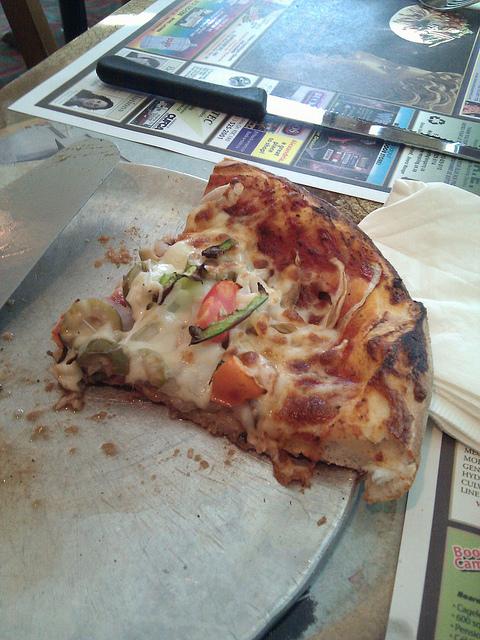How many pieces of pizza are there?
Write a very short answer. 1. What type of shop is this?
Keep it brief. Pizza. Is this a restaurant?
Quick response, please. Yes. Has anyone begun eating?
Keep it brief. Yes. What is in the plate?
Keep it brief. Pizza. 